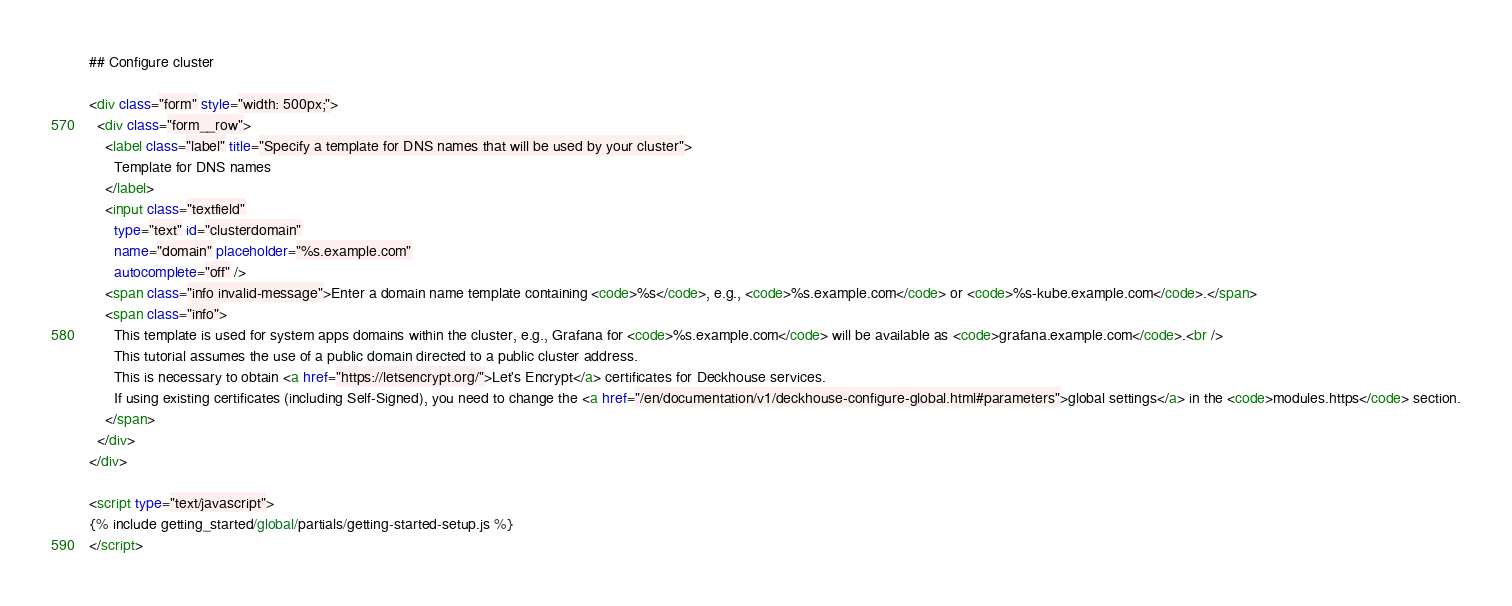<code> <loc_0><loc_0><loc_500><loc_500><_HTML_>## Configure cluster

<div class="form" style="width: 500px;">
  <div class="form__row">
    <label class="label" title="Specify a template for DNS names that will be used by your cluster">
      Template for DNS names
    </label>
    <input class="textfield"
      type="text" id="clusterdomain"
      name="domain" placeholder="%s.example.com"
      autocomplete="off" />
    <span class="info invalid-message">Enter a domain name template containing <code>%s</code>, e.g., <code>%s.example.com</code> or <code>%s-kube.example.com</code>.</span>
    <span class="info">
      This template is used for system apps domains within the cluster, e.g., Grafana for <code>%s.example.com</code> will be available as <code>grafana.example.com</code>.<br />
      This tutorial assumes the use of a public domain directed to a public cluster address.
      This is necessary to obtain <a href="https://letsencrypt.org/">Let's Encrypt</a> certificates for Deckhouse services.
      If using existing certificates (including Self-Signed), you need to change the <a href="/en/documentation/v1/deckhouse-configure-global.html#parameters">global settings</a> in the <code>modules.https</code> section.
    </span>
  </div>
</div>

<script type="text/javascript">
{% include getting_started/global/partials/getting-started-setup.js %}
</script>
</code> 